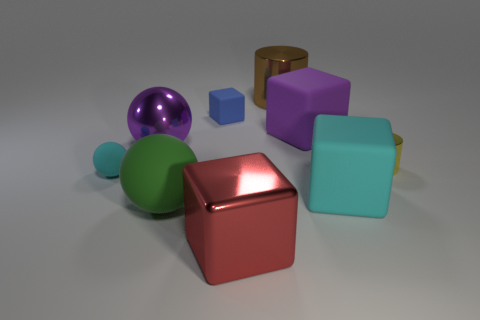Subtract 1 blocks. How many blocks are left? 3 Add 1 small red metallic balls. How many objects exist? 10 Subtract all cylinders. How many objects are left? 7 Subtract 0 yellow balls. How many objects are left? 9 Subtract all large cyan cubes. Subtract all big blue balls. How many objects are left? 8 Add 1 large cyan things. How many large cyan things are left? 2 Add 8 big purple shiny cubes. How many big purple shiny cubes exist? 8 